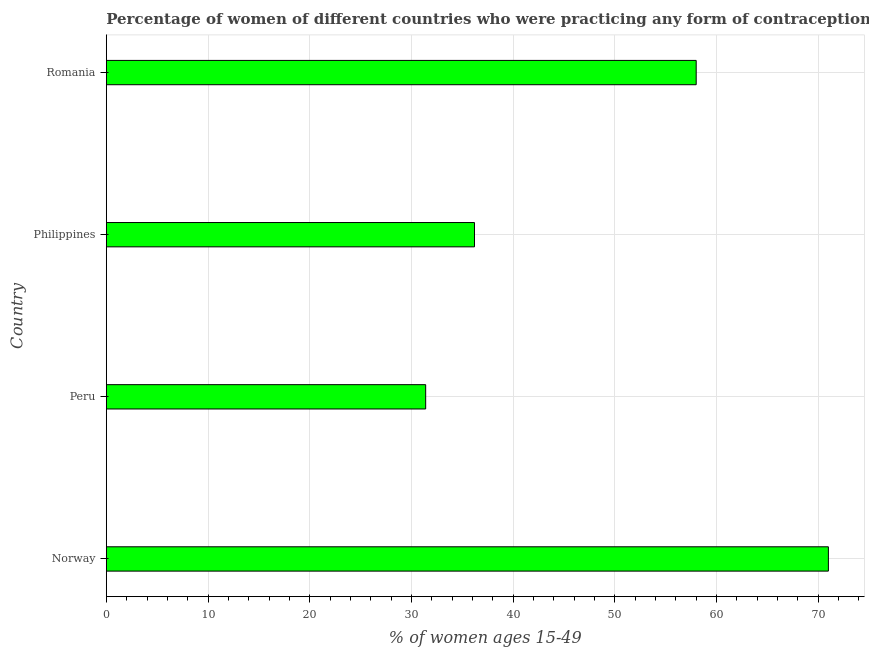Does the graph contain any zero values?
Ensure brevity in your answer.  No. Does the graph contain grids?
Make the answer very short. Yes. What is the title of the graph?
Your response must be concise. Percentage of women of different countries who were practicing any form of contraception in 1978. What is the label or title of the X-axis?
Ensure brevity in your answer.  % of women ages 15-49. What is the label or title of the Y-axis?
Provide a short and direct response. Country. What is the contraceptive prevalence in Peru?
Offer a very short reply. 31.4. Across all countries, what is the maximum contraceptive prevalence?
Your answer should be compact. 71. Across all countries, what is the minimum contraceptive prevalence?
Offer a terse response. 31.4. In which country was the contraceptive prevalence maximum?
Your answer should be very brief. Norway. In which country was the contraceptive prevalence minimum?
Your response must be concise. Peru. What is the sum of the contraceptive prevalence?
Your answer should be compact. 196.6. What is the average contraceptive prevalence per country?
Ensure brevity in your answer.  49.15. What is the median contraceptive prevalence?
Make the answer very short. 47.1. In how many countries, is the contraceptive prevalence greater than 44 %?
Keep it short and to the point. 2. What is the ratio of the contraceptive prevalence in Norway to that in Philippines?
Keep it short and to the point. 1.96. Is the contraceptive prevalence in Norway less than that in Romania?
Offer a terse response. No. What is the difference between the highest and the second highest contraceptive prevalence?
Your response must be concise. 13. Is the sum of the contraceptive prevalence in Philippines and Romania greater than the maximum contraceptive prevalence across all countries?
Offer a very short reply. Yes. What is the difference between the highest and the lowest contraceptive prevalence?
Your answer should be compact. 39.6. How many countries are there in the graph?
Offer a terse response. 4. Are the values on the major ticks of X-axis written in scientific E-notation?
Provide a short and direct response. No. What is the % of women ages 15-49 in Norway?
Give a very brief answer. 71. What is the % of women ages 15-49 in Peru?
Provide a short and direct response. 31.4. What is the % of women ages 15-49 of Philippines?
Keep it short and to the point. 36.2. What is the difference between the % of women ages 15-49 in Norway and Peru?
Offer a terse response. 39.6. What is the difference between the % of women ages 15-49 in Norway and Philippines?
Keep it short and to the point. 34.8. What is the difference between the % of women ages 15-49 in Peru and Philippines?
Ensure brevity in your answer.  -4.8. What is the difference between the % of women ages 15-49 in Peru and Romania?
Your response must be concise. -26.6. What is the difference between the % of women ages 15-49 in Philippines and Romania?
Offer a terse response. -21.8. What is the ratio of the % of women ages 15-49 in Norway to that in Peru?
Your response must be concise. 2.26. What is the ratio of the % of women ages 15-49 in Norway to that in Philippines?
Provide a succinct answer. 1.96. What is the ratio of the % of women ages 15-49 in Norway to that in Romania?
Your response must be concise. 1.22. What is the ratio of the % of women ages 15-49 in Peru to that in Philippines?
Provide a short and direct response. 0.87. What is the ratio of the % of women ages 15-49 in Peru to that in Romania?
Provide a succinct answer. 0.54. What is the ratio of the % of women ages 15-49 in Philippines to that in Romania?
Keep it short and to the point. 0.62. 